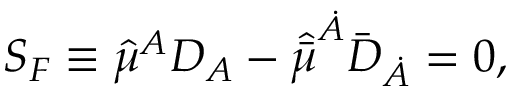<formula> <loc_0><loc_0><loc_500><loc_500>S _ { F } \equiv \hat { \mu } ^ { A } D _ { A } - \hat { \bar { \mu } } ^ { \dot { A } } { \bar { D } } _ { \dot { A } } = 0 ,</formula> 